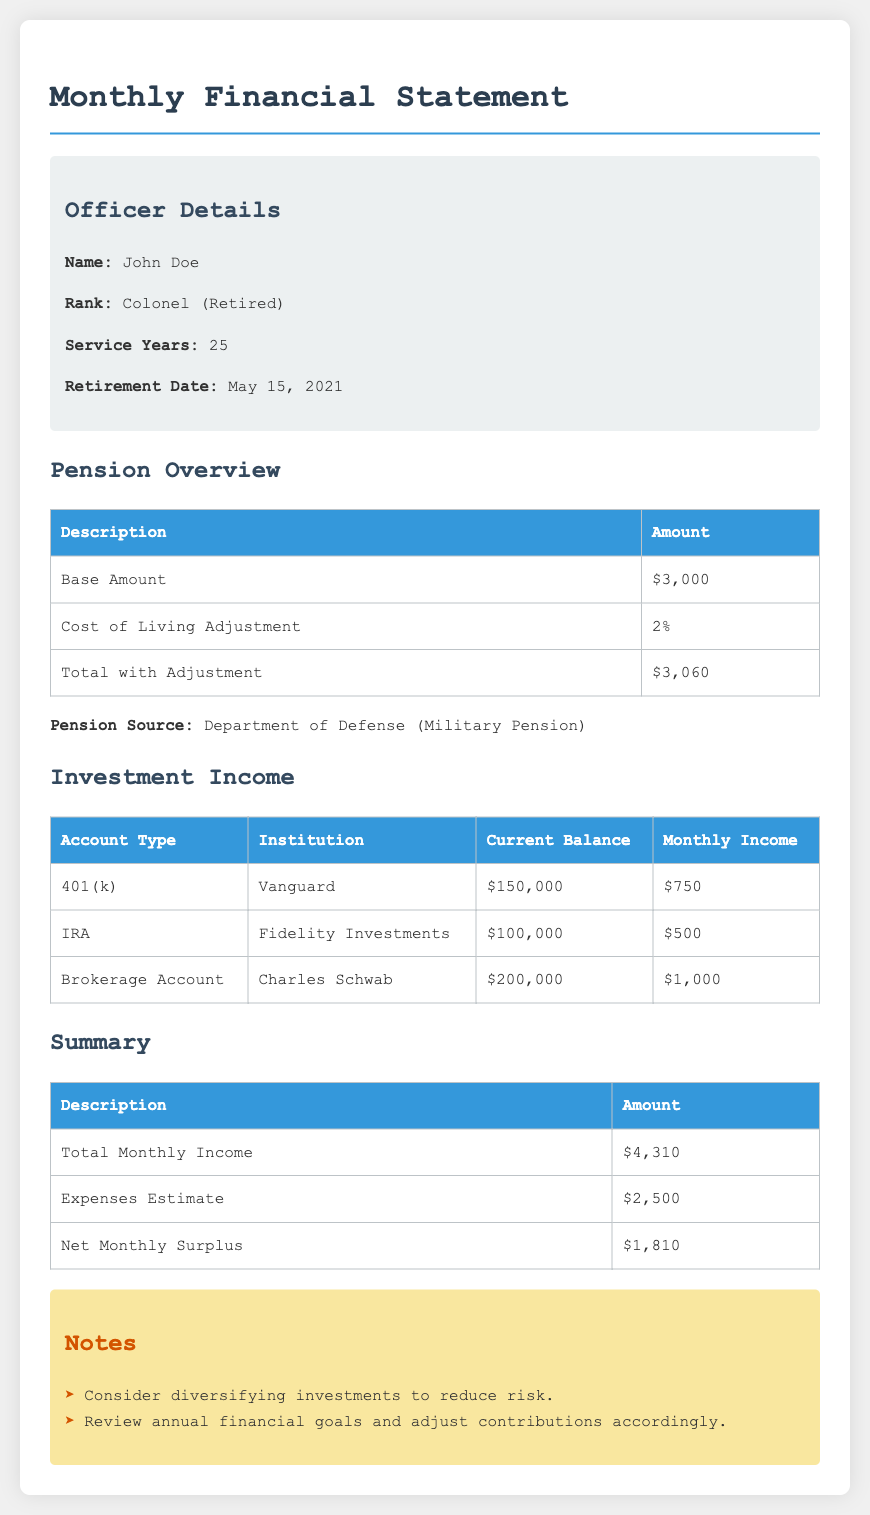What is the name of the officer? The officer's name is mentioned in the document.
Answer: John Doe What is the total monthly income? The total monthly income is a specific financial figure provided in the summary section.
Answer: $4,310 What percentage is the Cost of Living Adjustment? The document specifies this adjustment percentage in the pension overview.
Answer: 2% When was the officer retired? The retirement date is explicitly stated in the officer details section.
Answer: May 15, 2021 What is the current balance of the 401(k) account? The current balance for the 401(k) is detailed under investment income.
Answer: $150,000 What is the net monthly surplus? The net monthly surplus is provided in the summary based on income and expenses.
Answer: $1,810 Which institution manages the IRA account? The managing institution for the IRA account is mentioned in the investment income table.
Answer: Fidelity Investments What is the estimate for expenses? The expenses estimate is listed in the summary section of the document.
Answer: $2,500 What recommendation is indicated in the notes section? One of the notes suggests an action regarding investments.
Answer: Diversifying investments 